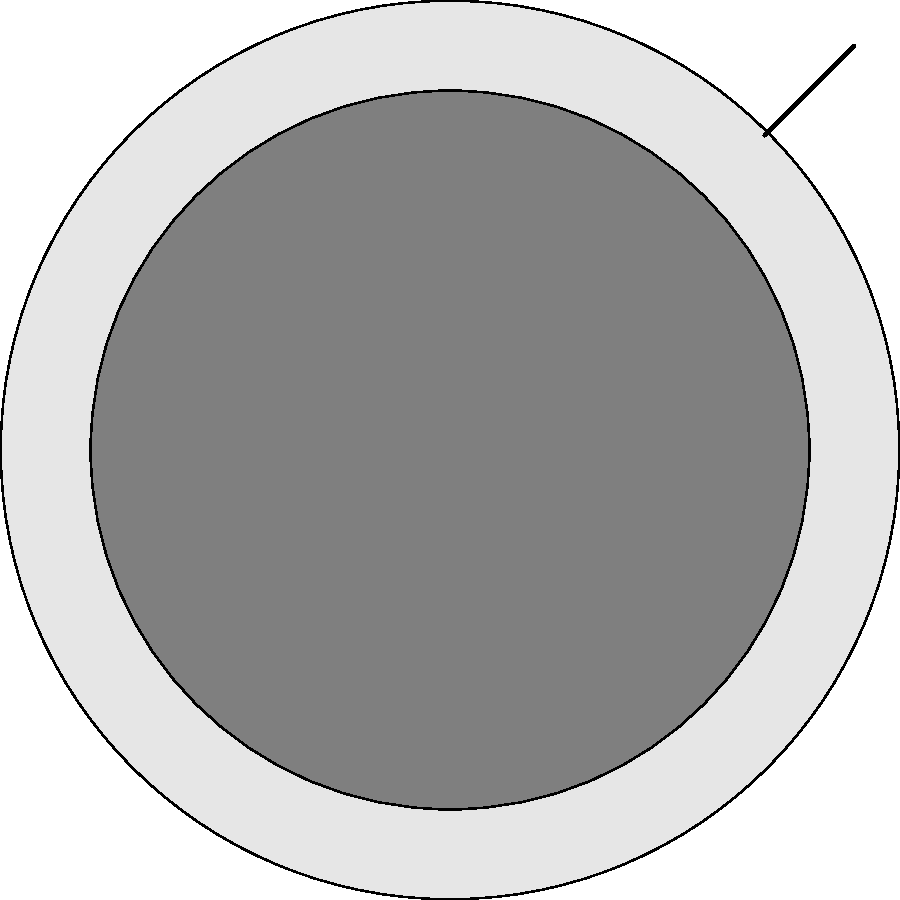In this diagram of a DJ turntable, which component is responsible for adjusting the speed of the record and is crucial for beatmatching in Hip Hop DJing? To answer this question, let's break down the components of the DJ turntable shown in the diagram:

1. Component A: This is the central circular part, which represents the platter. The platter holds and rotates the vinyl record.

2. Component B: This L-shaped part extending from the edge towards the center is the tonearm with the cartridge at its end. The tonearm holds the needle that reads the grooves on the vinyl.

3. Component C: This rectangular slider on the side of the turntable is the pitch control. It allows the DJ to adjust the speed of the platter, thereby changing the tempo of the music.

4. Component D: This small circular button near the edge is likely the start/stop button, used to begin or halt the rotation of the platter.

In Hip Hop DJing, beatmatching is a fundamental technique where the DJ synchronizes the tempos of two tracks to create seamless transitions or layered beats. The pitch control (Component C) is crucial for this process as it allows the DJ to fine-tune the speed of one record to match another.

Therefore, the component responsible for adjusting the speed of the record and crucial for beatmatching in Hip Hop DJing is the pitch control, labeled as C in the diagram.
Answer: Pitch control (C) 